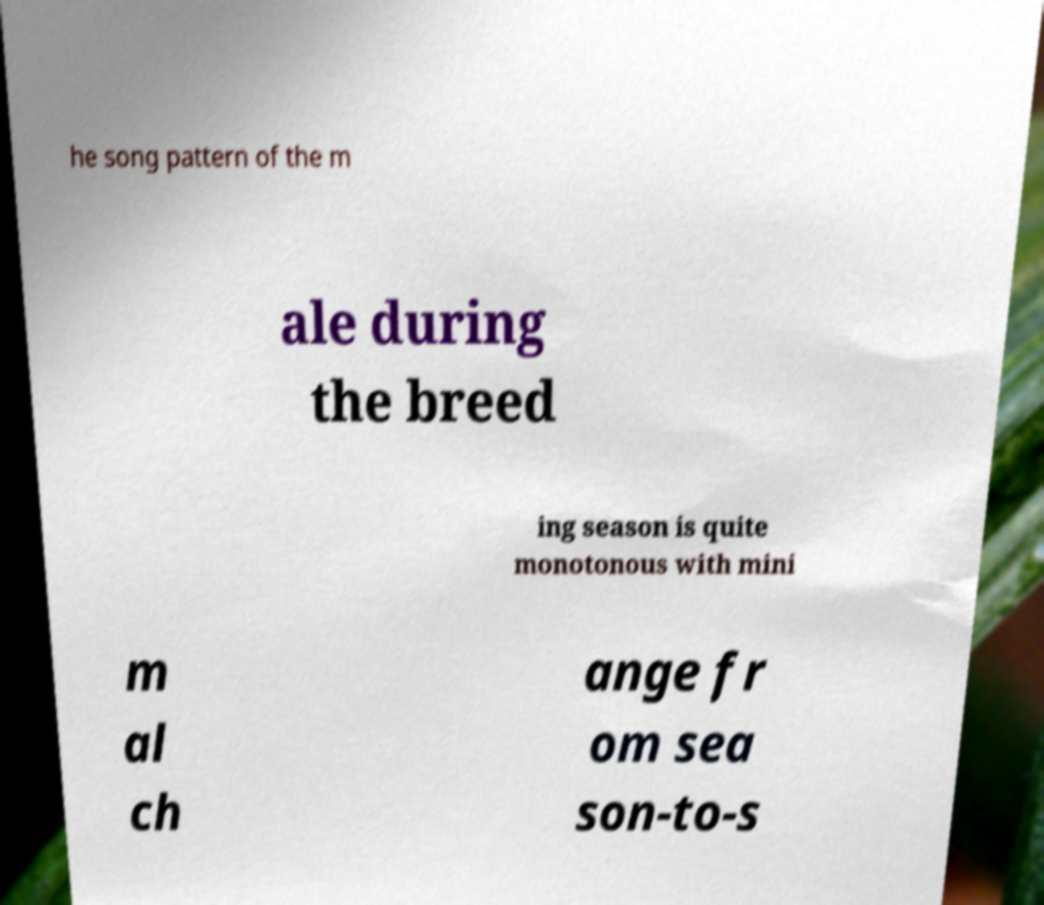Could you extract and type out the text from this image? he song pattern of the m ale during the breed ing season is quite monotonous with mini m al ch ange fr om sea son-to-s 